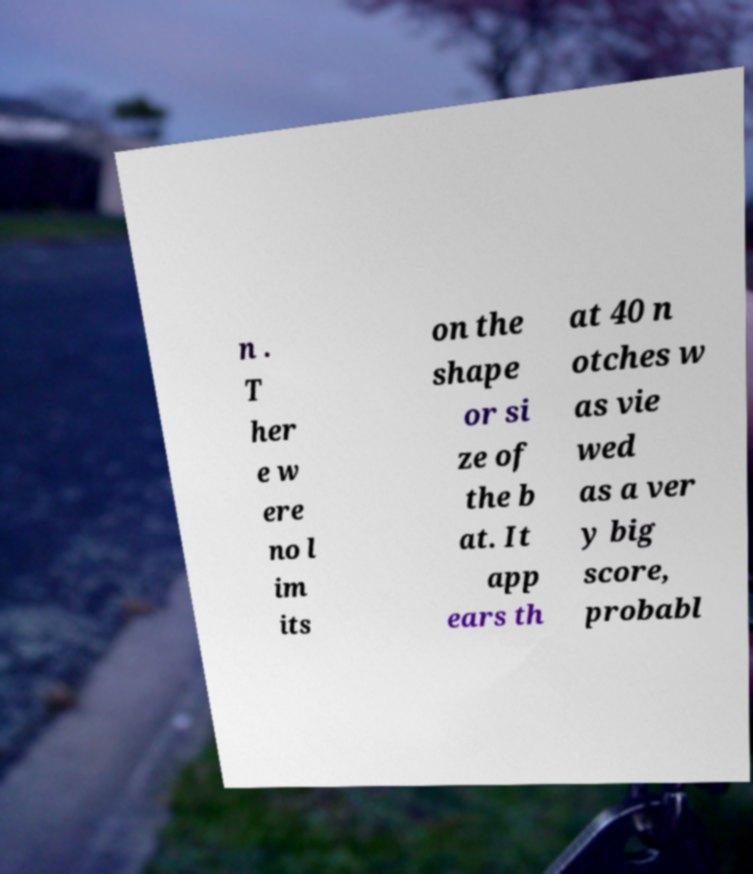Please read and relay the text visible in this image. What does it say? n . T her e w ere no l im its on the shape or si ze of the b at. It app ears th at 40 n otches w as vie wed as a ver y big score, probabl 